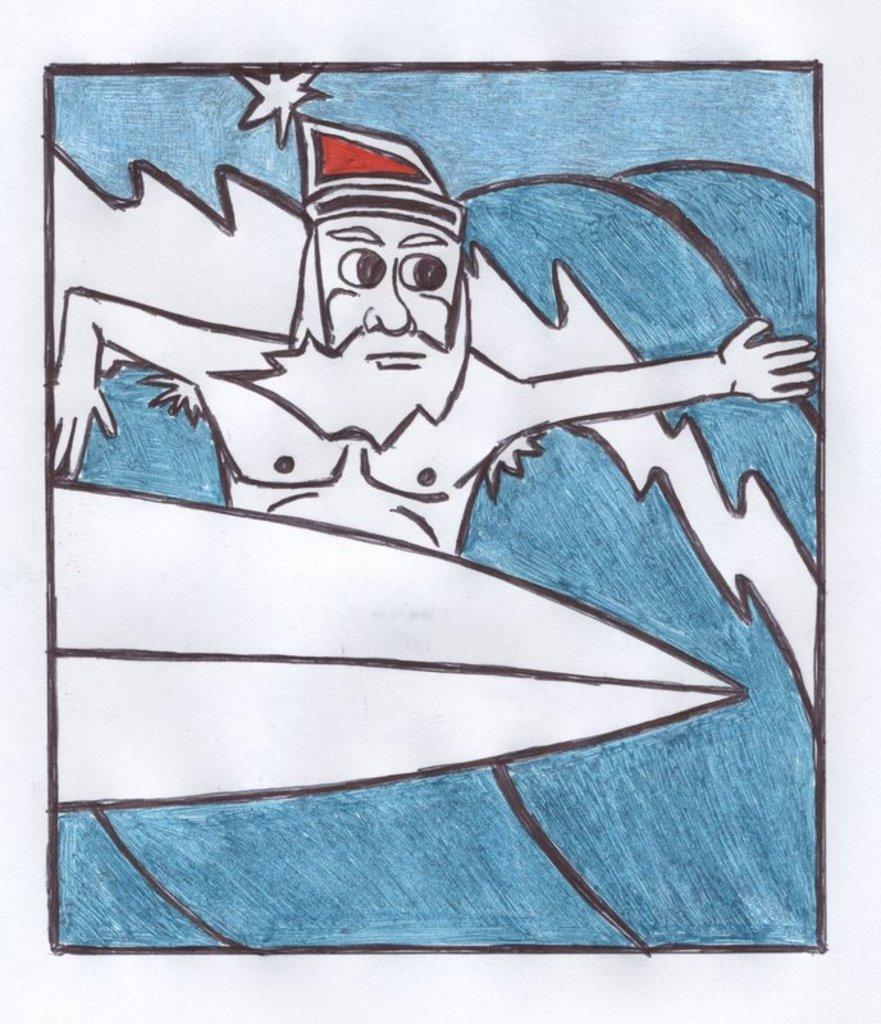What is depicted in the image? The image contains a sketch of a person. What activity is the person in the sketch engaged in? The person in the sketch is surfing. What type of dish is the person in the sketch cooking in the image? There is no dish or cooking activity present in the image; it features a sketch of a person surfing. What type of musical harmony is being played in the image? There is no musical instrument or harmony present in the image; it features a sketch of a person surfing. 